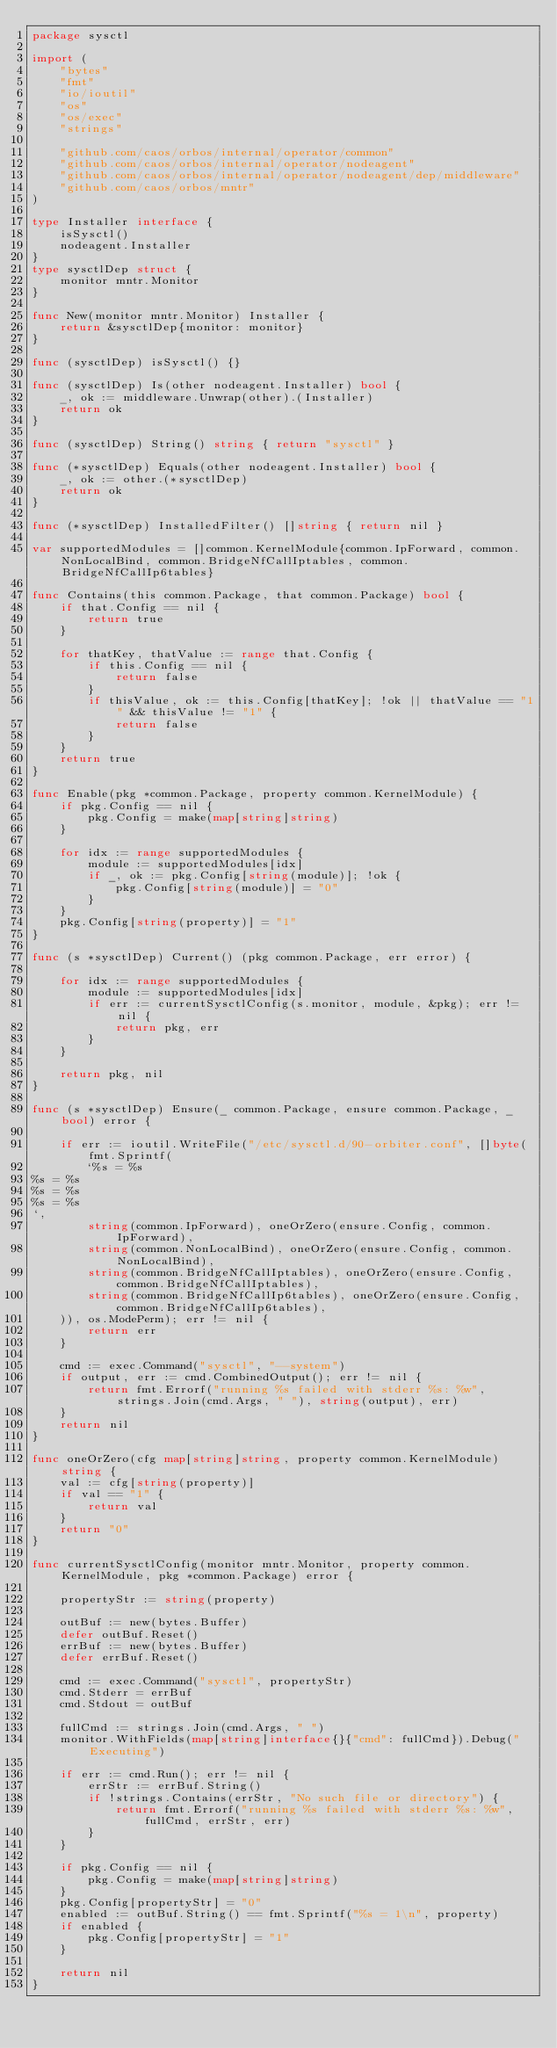<code> <loc_0><loc_0><loc_500><loc_500><_Go_>package sysctl

import (
	"bytes"
	"fmt"
	"io/ioutil"
	"os"
	"os/exec"
	"strings"

	"github.com/caos/orbos/internal/operator/common"
	"github.com/caos/orbos/internal/operator/nodeagent"
	"github.com/caos/orbos/internal/operator/nodeagent/dep/middleware"
	"github.com/caos/orbos/mntr"
)

type Installer interface {
	isSysctl()
	nodeagent.Installer
}
type sysctlDep struct {
	monitor mntr.Monitor
}

func New(monitor mntr.Monitor) Installer {
	return &sysctlDep{monitor: monitor}
}

func (sysctlDep) isSysctl() {}

func (sysctlDep) Is(other nodeagent.Installer) bool {
	_, ok := middleware.Unwrap(other).(Installer)
	return ok
}

func (sysctlDep) String() string { return "sysctl" }

func (*sysctlDep) Equals(other nodeagent.Installer) bool {
	_, ok := other.(*sysctlDep)
	return ok
}

func (*sysctlDep) InstalledFilter() []string { return nil }

var supportedModules = []common.KernelModule{common.IpForward, common.NonLocalBind, common.BridgeNfCallIptables, common.BridgeNfCallIp6tables}

func Contains(this common.Package, that common.Package) bool {
	if that.Config == nil {
		return true
	}

	for thatKey, thatValue := range that.Config {
		if this.Config == nil {
			return false
		}
		if thisValue, ok := this.Config[thatKey]; !ok || thatValue == "1" && thisValue != "1" {
			return false
		}
	}
	return true
}

func Enable(pkg *common.Package, property common.KernelModule) {
	if pkg.Config == nil {
		pkg.Config = make(map[string]string)
	}

	for idx := range supportedModules {
		module := supportedModules[idx]
		if _, ok := pkg.Config[string(module)]; !ok {
			pkg.Config[string(module)] = "0"
		}
	}
	pkg.Config[string(property)] = "1"
}

func (s *sysctlDep) Current() (pkg common.Package, err error) {

	for idx := range supportedModules {
		module := supportedModules[idx]
		if err := currentSysctlConfig(s.monitor, module, &pkg); err != nil {
			return pkg, err
		}
	}

	return pkg, nil
}

func (s *sysctlDep) Ensure(_ common.Package, ensure common.Package, _ bool) error {

	if err := ioutil.WriteFile("/etc/sysctl.d/90-orbiter.conf", []byte(fmt.Sprintf(
		`%s = %s
%s = %s
%s = %s
%s = %s
`,
		string(common.IpForward), oneOrZero(ensure.Config, common.IpForward),
		string(common.NonLocalBind), oneOrZero(ensure.Config, common.NonLocalBind),
		string(common.BridgeNfCallIptables), oneOrZero(ensure.Config, common.BridgeNfCallIptables),
		string(common.BridgeNfCallIp6tables), oneOrZero(ensure.Config, common.BridgeNfCallIp6tables),
	)), os.ModePerm); err != nil {
		return err
	}

	cmd := exec.Command("sysctl", "--system")
	if output, err := cmd.CombinedOutput(); err != nil {
		return fmt.Errorf("running %s failed with stderr %s: %w", strings.Join(cmd.Args, " "), string(output), err)
	}
	return nil
}

func oneOrZero(cfg map[string]string, property common.KernelModule) string {
	val := cfg[string(property)]
	if val == "1" {
		return val
	}
	return "0"
}

func currentSysctlConfig(monitor mntr.Monitor, property common.KernelModule, pkg *common.Package) error {

	propertyStr := string(property)

	outBuf := new(bytes.Buffer)
	defer outBuf.Reset()
	errBuf := new(bytes.Buffer)
	defer errBuf.Reset()

	cmd := exec.Command("sysctl", propertyStr)
	cmd.Stderr = errBuf
	cmd.Stdout = outBuf

	fullCmd := strings.Join(cmd.Args, " ")
	monitor.WithFields(map[string]interface{}{"cmd": fullCmd}).Debug("Executing")

	if err := cmd.Run(); err != nil {
		errStr := errBuf.String()
		if !strings.Contains(errStr, "No such file or directory") {
			return fmt.Errorf("running %s failed with stderr %s: %w", fullCmd, errStr, err)
		}
	}

	if pkg.Config == nil {
		pkg.Config = make(map[string]string)
	}
	pkg.Config[propertyStr] = "0"
	enabled := outBuf.String() == fmt.Sprintf("%s = 1\n", property)
	if enabled {
		pkg.Config[propertyStr] = "1"
	}

	return nil
}
</code> 